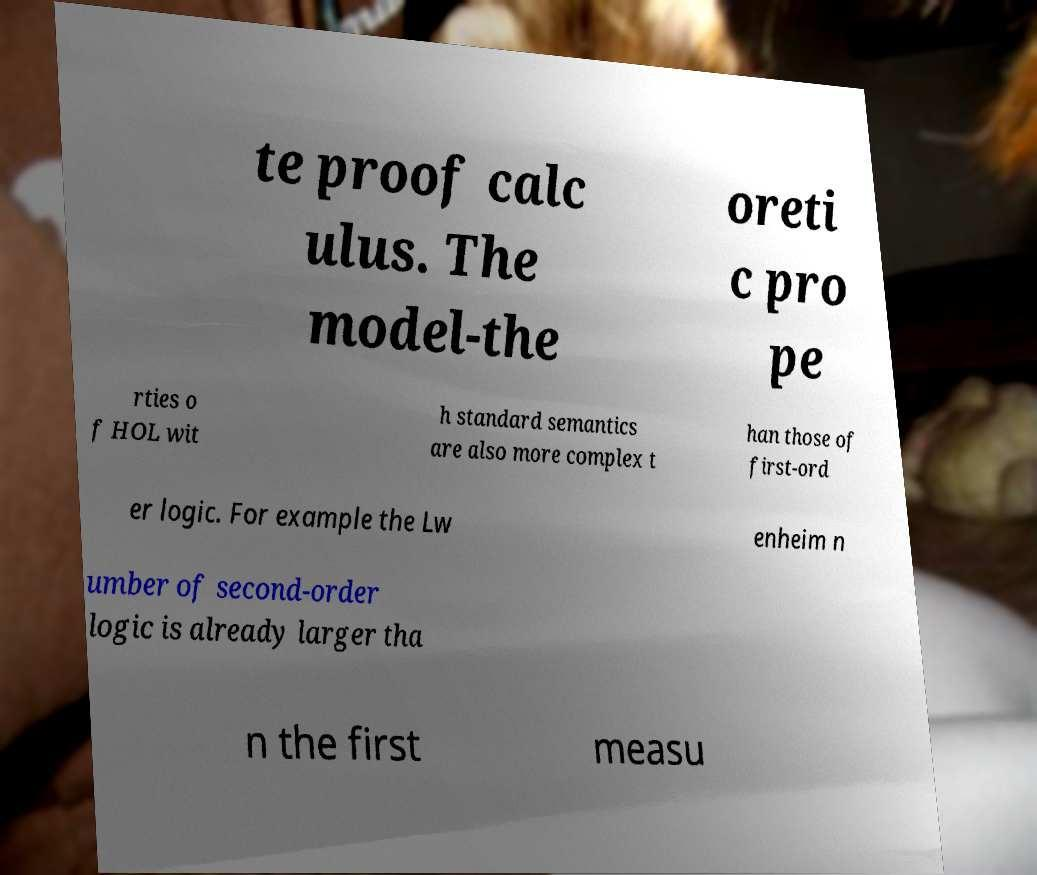Can you accurately transcribe the text from the provided image for me? te proof calc ulus. The model-the oreti c pro pe rties o f HOL wit h standard semantics are also more complex t han those of first-ord er logic. For example the Lw enheim n umber of second-order logic is already larger tha n the first measu 